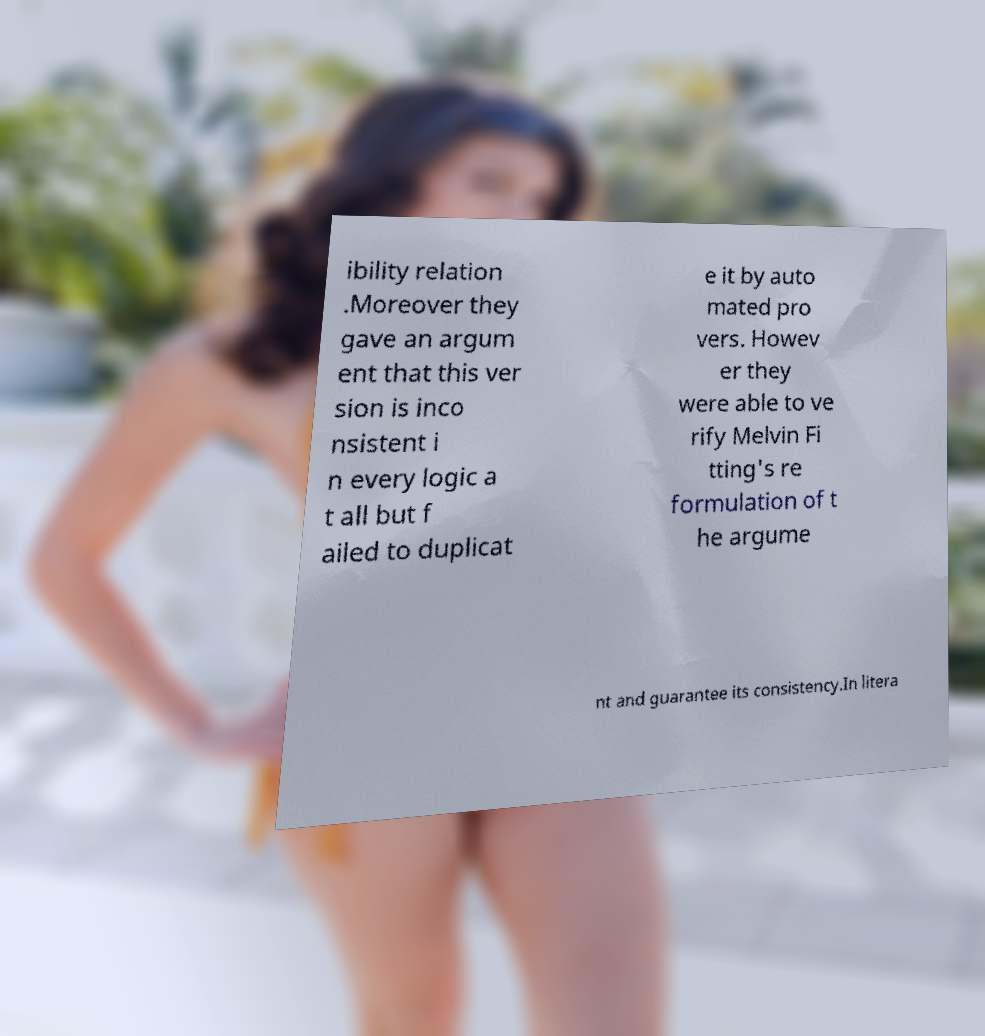Could you assist in decoding the text presented in this image and type it out clearly? ibility relation .Moreover they gave an argum ent that this ver sion is inco nsistent i n every logic a t all but f ailed to duplicat e it by auto mated pro vers. Howev er they were able to ve rify Melvin Fi tting's re formulation of t he argume nt and guarantee its consistency.In litera 